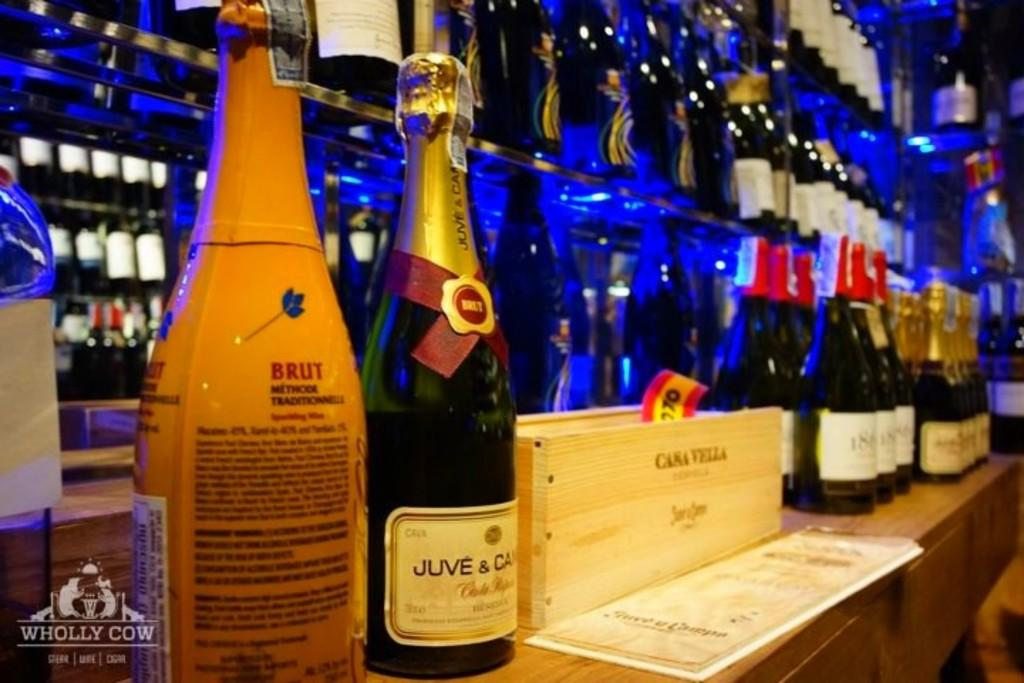<image>
Create a compact narrative representing the image presented. Some bottles of champagne, one of which is Brut. 